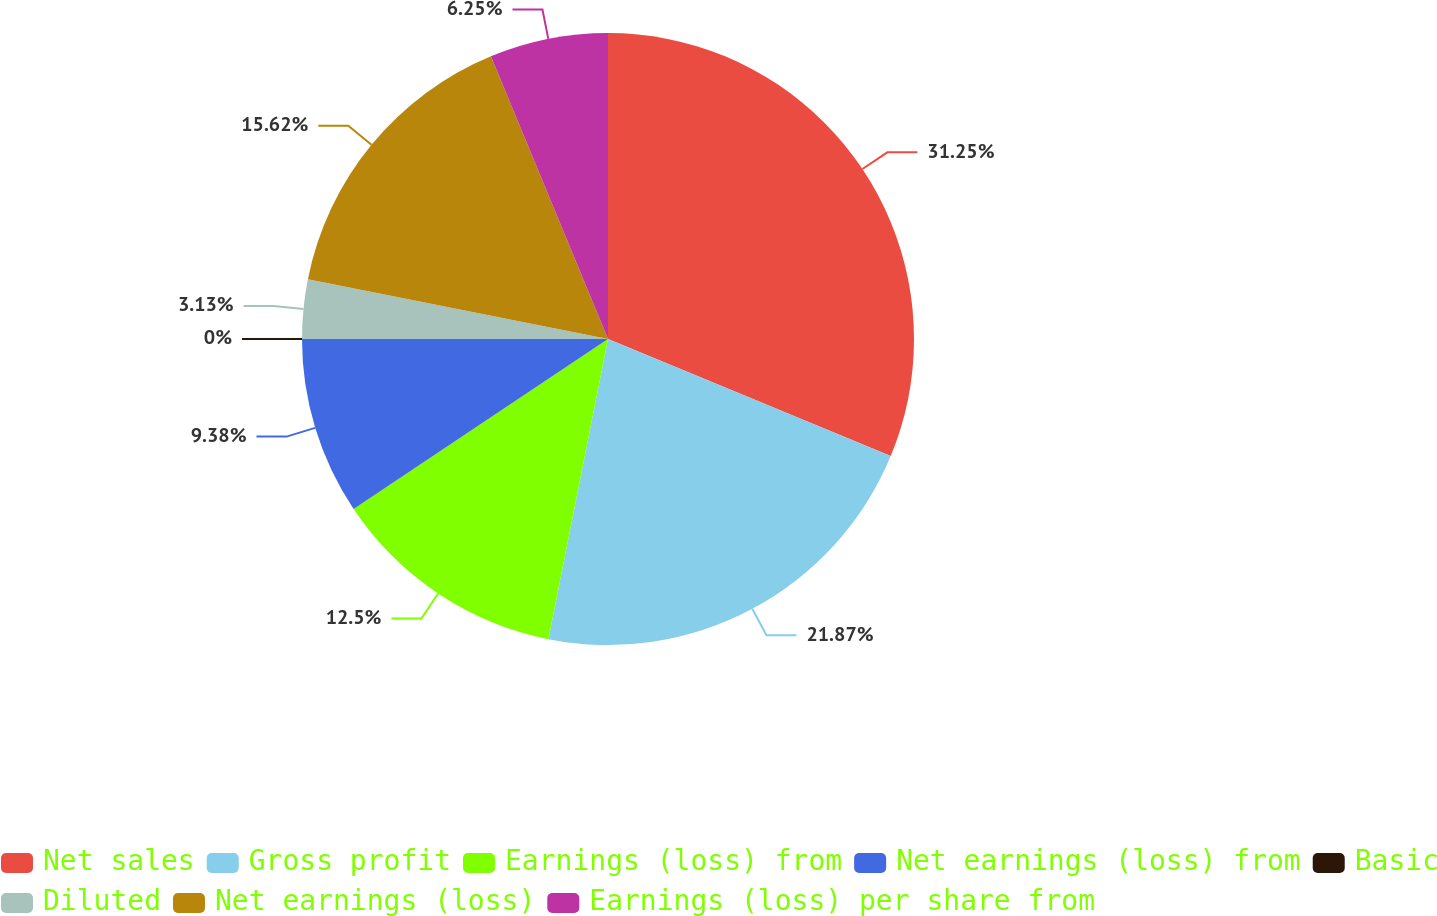Convert chart to OTSL. <chart><loc_0><loc_0><loc_500><loc_500><pie_chart><fcel>Net sales<fcel>Gross profit<fcel>Earnings (loss) from<fcel>Net earnings (loss) from<fcel>Basic<fcel>Diluted<fcel>Net earnings (loss)<fcel>Earnings (loss) per share from<nl><fcel>31.25%<fcel>21.87%<fcel>12.5%<fcel>9.38%<fcel>0.0%<fcel>3.13%<fcel>15.62%<fcel>6.25%<nl></chart> 